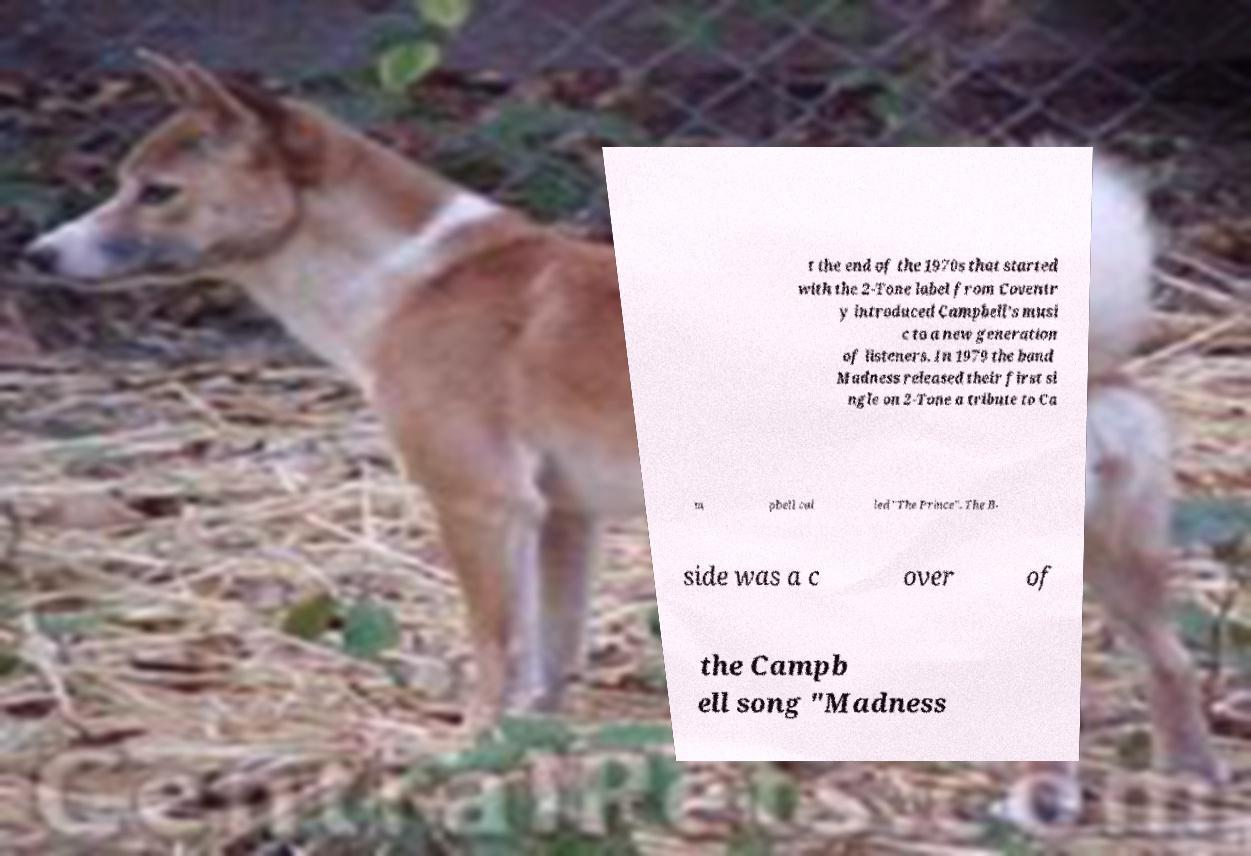For documentation purposes, I need the text within this image transcribed. Could you provide that? t the end of the 1970s that started with the 2-Tone label from Coventr y introduced Campbell's musi c to a new generation of listeners. In 1979 the band Madness released their first si ngle on 2-Tone a tribute to Ca m pbell cal led "The Prince". The B- side was a c over of the Campb ell song "Madness 